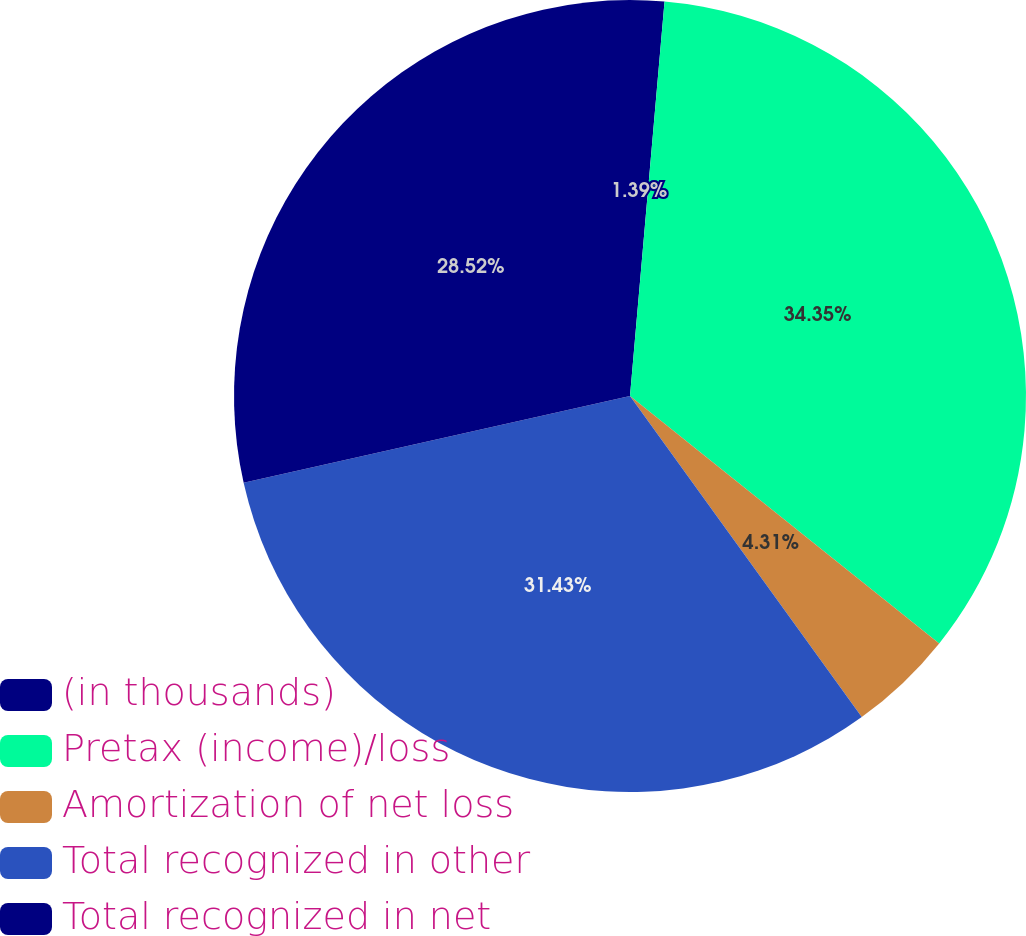Convert chart to OTSL. <chart><loc_0><loc_0><loc_500><loc_500><pie_chart><fcel>(in thousands)<fcel>Pretax (income)/loss<fcel>Amortization of net loss<fcel>Total recognized in other<fcel>Total recognized in net<nl><fcel>1.39%<fcel>34.35%<fcel>4.31%<fcel>31.43%<fcel>28.52%<nl></chart> 